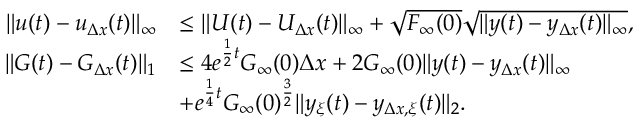<formula> <loc_0><loc_0><loc_500><loc_500>\begin{array} { r l } { \| u ( t ) - u _ { \Delta x } ( t ) \| _ { \infty } } & { \leq \| U ( t ) - U _ { \Delta x } ( t ) \| _ { \infty } + \sqrt { F _ { \infty } ( 0 ) } \sqrt { \| y ( t ) - y _ { \Delta x } ( t ) \| _ { \infty } } , } \\ { \| G ( t ) - G _ { \Delta x } ( t ) \| _ { 1 } } & { \leq 4 e ^ { \frac { 1 } { 2 } t } G _ { \infty } ( 0 ) \Delta x + 2 G _ { \infty } ( 0 ) \| y ( t ) - y _ { \Delta x } ( t ) \| _ { \infty } } \\ & { + e ^ { \frac { 1 } { 4 } t } G _ { \infty } ( 0 ) ^ { \frac { 3 } { 2 } } \| y _ { \xi } ( t ) - y _ { \Delta x , \xi } ( t ) \| _ { 2 } . } \end{array}</formula> 